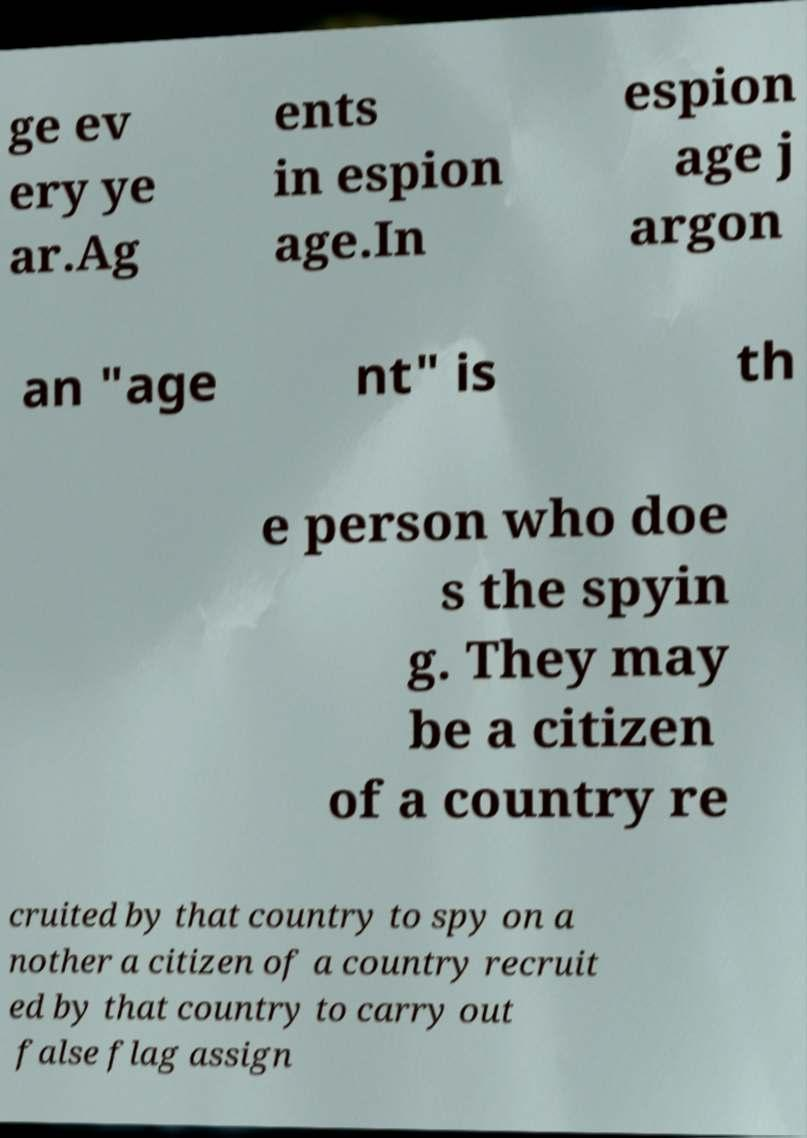I need the written content from this picture converted into text. Can you do that? ge ev ery ye ar.Ag ents in espion age.In espion age j argon an "age nt" is th e person who doe s the spyin g. They may be a citizen of a country re cruited by that country to spy on a nother a citizen of a country recruit ed by that country to carry out false flag assign 